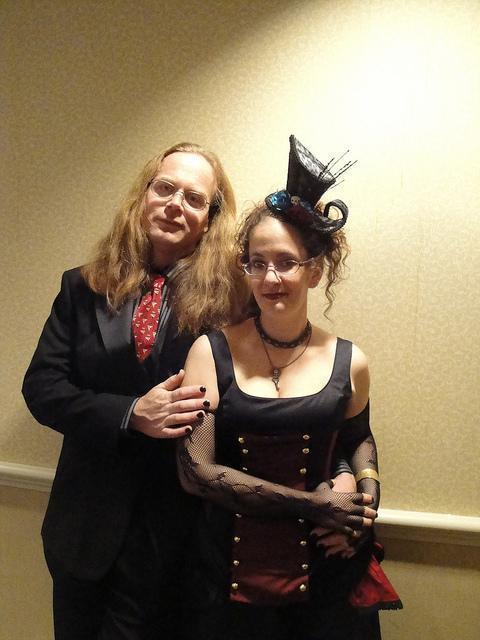Why is the woman wearing a hat?
Choose the correct response, then elucidate: 'Answer: answer
Rationale: rationale.'
Options: Costume, warmth, safety, uniform. Answer: costume.
Rationale: They are dressed up for a party 